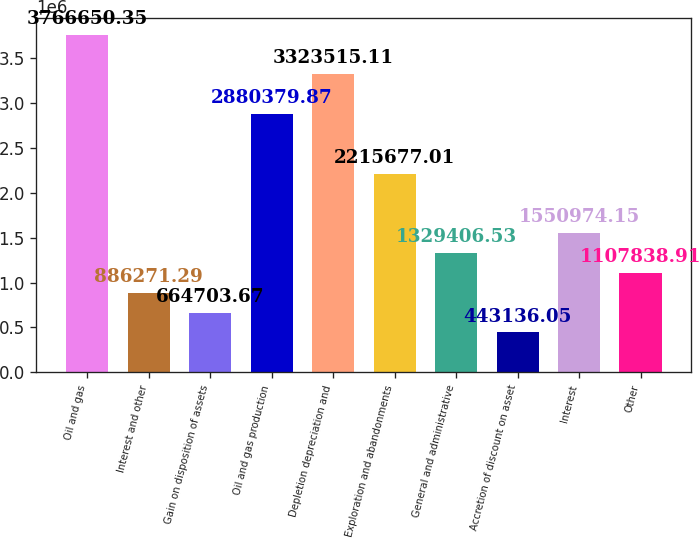Convert chart to OTSL. <chart><loc_0><loc_0><loc_500><loc_500><bar_chart><fcel>Oil and gas<fcel>Interest and other<fcel>Gain on disposition of assets<fcel>Oil and gas production<fcel>Depletion depreciation and<fcel>Exploration and abandonments<fcel>General and administrative<fcel>Accretion of discount on asset<fcel>Interest<fcel>Other<nl><fcel>3.76665e+06<fcel>886271<fcel>664704<fcel>2.88038e+06<fcel>3.32352e+06<fcel>2.21568e+06<fcel>1.32941e+06<fcel>443136<fcel>1.55097e+06<fcel>1.10784e+06<nl></chart> 